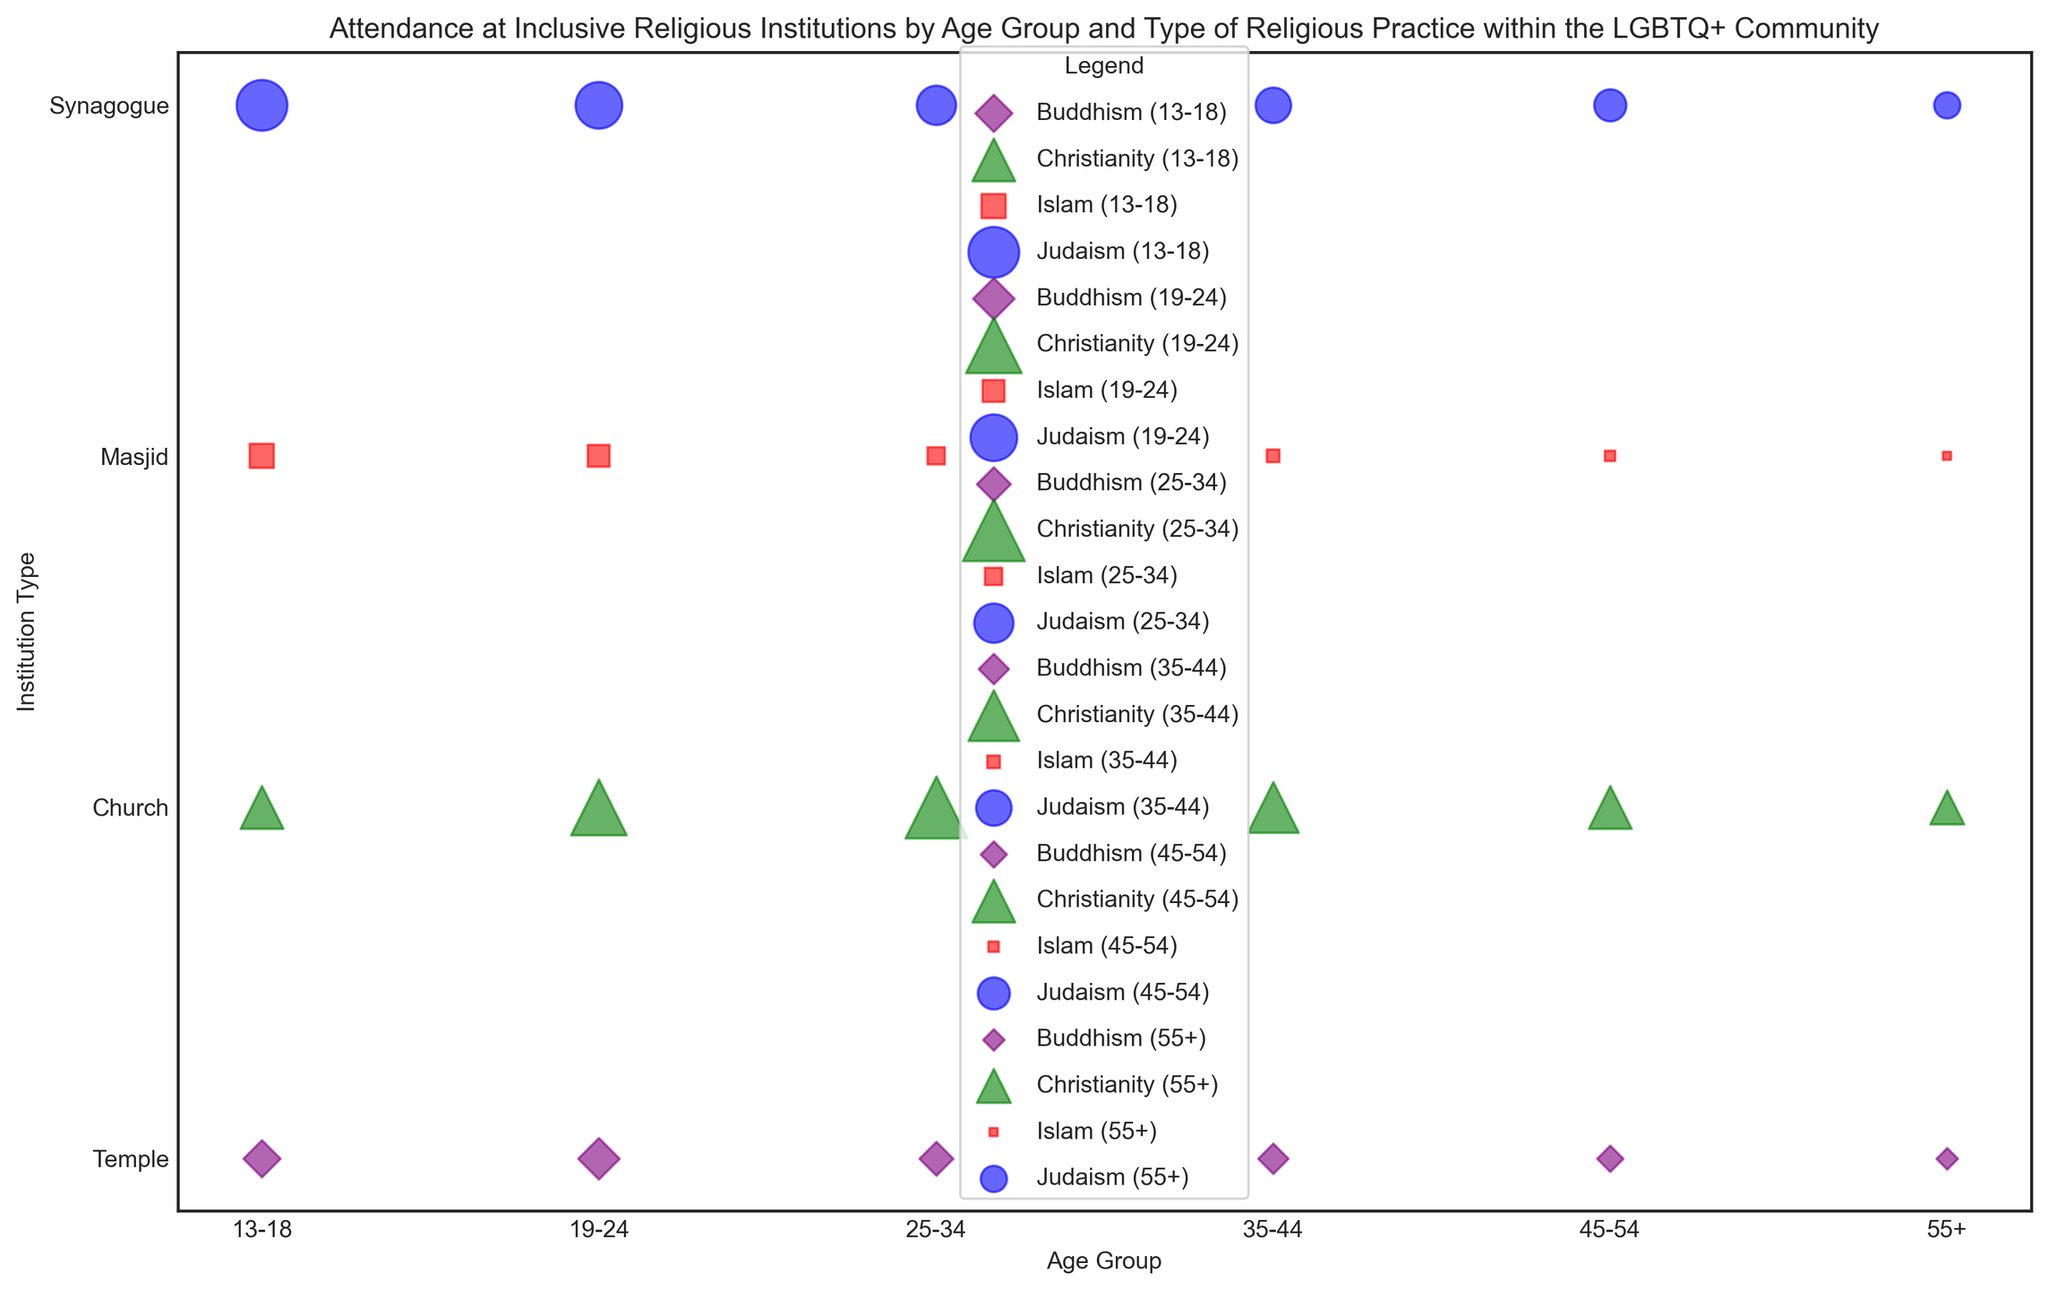Which age group has the highest attendance in Churches? From the figure, observe the size of the bubbles representing Church attendance across all age groups. The largest bubble is for the 25-34 age group.
Answer: 25-34 Which religion's attendance in Temples is largest for the 19-24 age group? Identify the bubbles corresponding to each religious practice for the 19-24 age group and focus on Temples. The largest bubble here is purple, representing Buddhism.
Answer: Buddhism Is the attendance at Synagogues greater for the 13-18 age group compared to the 35-44 age group? Compare the sizes of the blue bubbles (Synagogue attendance) for the 13-18 and 35-44 age groups. The bubble for the 13-18 group is larger.
Answer: Yes What is the total combined attendance for Judaism across all age groups? Add the sizes of the blue bubbles (representing Judaism) across all age groups: 45 + 38 + 27 + 22 + 18 + 12 = 162.
Answer: 162 Compare the attendance at Masjids for the 19-24 and 45-54 age groups. Which one is higher? Examine the sizes of the red bubbles (Islam attendance) for both the 19-24 and 45-54 age groups. The 19-24 bubble is larger.
Answer: 19-24 Which age group's Synagogue attendance is approximately half of their Church attendance? For age groups with both Synagogue and Church bubbles, compare the bubble sizes to see which one shows Synagogue attendance being about half of Church attendance. For the 19-24 group: Synagogue (38) is roughly half of Church (54).
Answer: 19-24 What is the difference in attendance between Churches and Masjids for the 35-44 age group? Subtract the number of attendees for Masjids from Churches in the 35-44 group: 45 - 3 = 42.
Answer: 42 Which religious practice shows an increasing trend in attendance as age progresses? Examine the trend of bubble sizes for each religious practice across age groups. Christianity (green bubbles) generally shows an increase in bubble size from younger to older age groups.
Answer: Christianity How does attendance in Temples vary between the 55+ and 13-18 age groups? Compare the sizes of the purple bubbles (Buddhism attendance) for the 55+ and 13-18 groups. The 13-18 bubble is larger.
Answer: Larger in 13-18 Which age group has the smallest attendance for Islam? Identify the smallest red bubble on the chart, which represents the 55+ age group with the smallest attendance for Masjid.
Answer: 55+ 